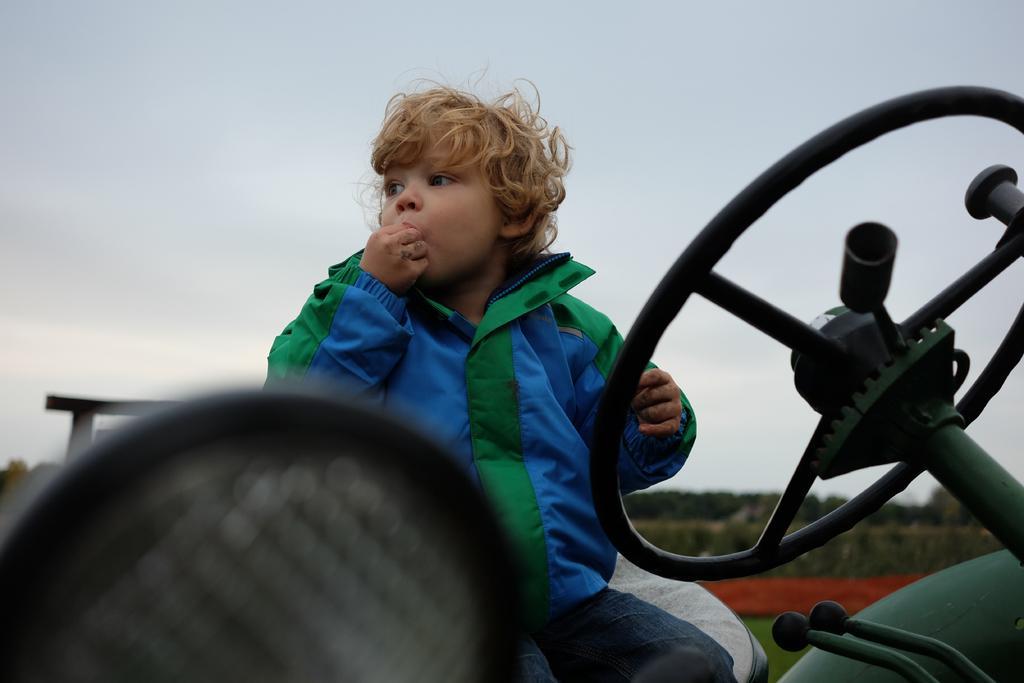Describe this image in one or two sentences. In this image I can see a boy wearing a jacket. i can also see he is sitting in a vehicle. One of his hand is near his mouth. 